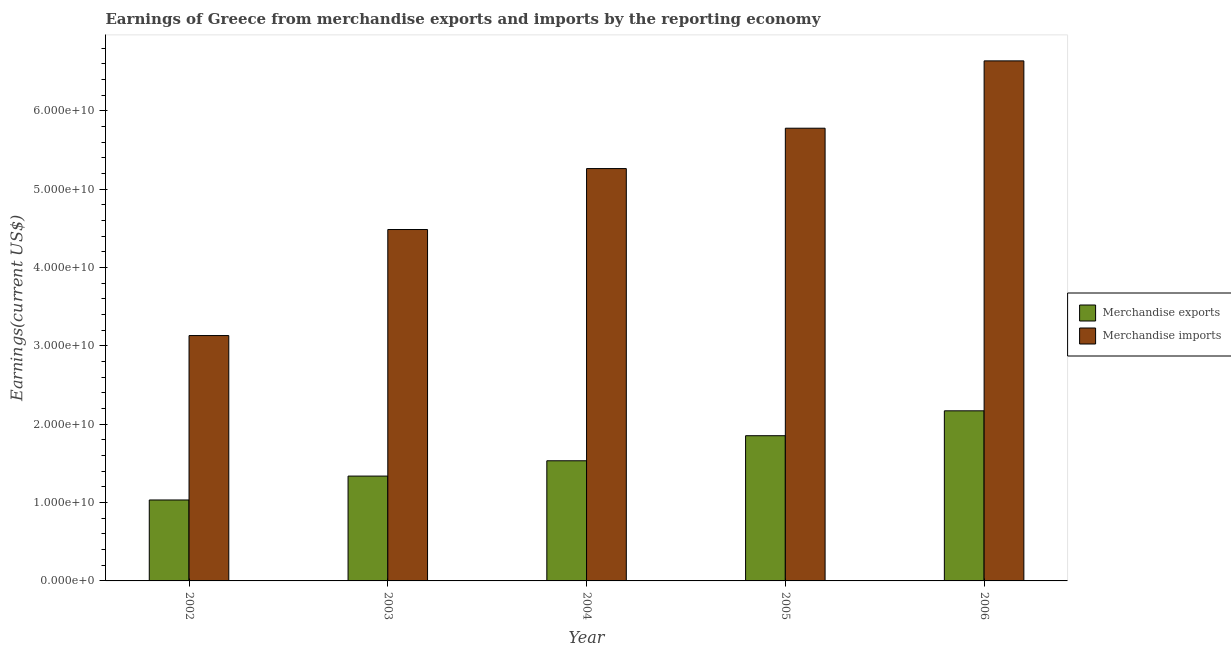How many different coloured bars are there?
Provide a succinct answer. 2. Are the number of bars per tick equal to the number of legend labels?
Make the answer very short. Yes. Are the number of bars on each tick of the X-axis equal?
Your answer should be compact. Yes. How many bars are there on the 1st tick from the right?
Offer a terse response. 2. What is the earnings from merchandise imports in 2005?
Your response must be concise. 5.78e+1. Across all years, what is the maximum earnings from merchandise exports?
Provide a succinct answer. 2.17e+1. Across all years, what is the minimum earnings from merchandise exports?
Your answer should be compact. 1.03e+1. In which year was the earnings from merchandise exports minimum?
Keep it short and to the point. 2002. What is the total earnings from merchandise exports in the graph?
Ensure brevity in your answer.  7.93e+1. What is the difference between the earnings from merchandise imports in 2002 and that in 2006?
Your response must be concise. -3.51e+1. What is the difference between the earnings from merchandise exports in 2003 and the earnings from merchandise imports in 2005?
Provide a short and direct response. -5.15e+09. What is the average earnings from merchandise exports per year?
Give a very brief answer. 1.59e+1. What is the ratio of the earnings from merchandise imports in 2002 to that in 2004?
Your answer should be compact. 0.6. Is the earnings from merchandise exports in 2004 less than that in 2005?
Ensure brevity in your answer.  Yes. Is the difference between the earnings from merchandise imports in 2003 and 2005 greater than the difference between the earnings from merchandise exports in 2003 and 2005?
Your response must be concise. No. What is the difference between the highest and the second highest earnings from merchandise imports?
Provide a succinct answer. 8.60e+09. What is the difference between the highest and the lowest earnings from merchandise imports?
Make the answer very short. 3.51e+1. What does the 2nd bar from the left in 2003 represents?
Make the answer very short. Merchandise imports. How many bars are there?
Your response must be concise. 10. Are all the bars in the graph horizontal?
Keep it short and to the point. No. How many years are there in the graph?
Provide a short and direct response. 5. Are the values on the major ticks of Y-axis written in scientific E-notation?
Your answer should be very brief. Yes. Does the graph contain any zero values?
Offer a terse response. No. Where does the legend appear in the graph?
Keep it short and to the point. Center right. How are the legend labels stacked?
Keep it short and to the point. Vertical. What is the title of the graph?
Your answer should be compact. Earnings of Greece from merchandise exports and imports by the reporting economy. What is the label or title of the Y-axis?
Provide a short and direct response. Earnings(current US$). What is the Earnings(current US$) in Merchandise exports in 2002?
Ensure brevity in your answer.  1.03e+1. What is the Earnings(current US$) in Merchandise imports in 2002?
Offer a very short reply. 3.13e+1. What is the Earnings(current US$) of Merchandise exports in 2003?
Give a very brief answer. 1.34e+1. What is the Earnings(current US$) of Merchandise imports in 2003?
Ensure brevity in your answer.  4.49e+1. What is the Earnings(current US$) in Merchandise exports in 2004?
Provide a short and direct response. 1.53e+1. What is the Earnings(current US$) of Merchandise imports in 2004?
Provide a succinct answer. 5.26e+1. What is the Earnings(current US$) of Merchandise exports in 2005?
Keep it short and to the point. 1.85e+1. What is the Earnings(current US$) in Merchandise imports in 2005?
Your answer should be very brief. 5.78e+1. What is the Earnings(current US$) of Merchandise exports in 2006?
Ensure brevity in your answer.  2.17e+1. What is the Earnings(current US$) of Merchandise imports in 2006?
Your answer should be very brief. 6.64e+1. Across all years, what is the maximum Earnings(current US$) of Merchandise exports?
Offer a terse response. 2.17e+1. Across all years, what is the maximum Earnings(current US$) in Merchandise imports?
Offer a very short reply. 6.64e+1. Across all years, what is the minimum Earnings(current US$) of Merchandise exports?
Your answer should be very brief. 1.03e+1. Across all years, what is the minimum Earnings(current US$) in Merchandise imports?
Offer a very short reply. 3.13e+1. What is the total Earnings(current US$) in Merchandise exports in the graph?
Give a very brief answer. 7.93e+1. What is the total Earnings(current US$) of Merchandise imports in the graph?
Offer a very short reply. 2.53e+11. What is the difference between the Earnings(current US$) in Merchandise exports in 2002 and that in 2003?
Ensure brevity in your answer.  -3.05e+09. What is the difference between the Earnings(current US$) of Merchandise imports in 2002 and that in 2003?
Offer a terse response. -1.35e+1. What is the difference between the Earnings(current US$) of Merchandise exports in 2002 and that in 2004?
Provide a succinct answer. -5.00e+09. What is the difference between the Earnings(current US$) in Merchandise imports in 2002 and that in 2004?
Make the answer very short. -2.13e+1. What is the difference between the Earnings(current US$) in Merchandise exports in 2002 and that in 2005?
Ensure brevity in your answer.  -8.20e+09. What is the difference between the Earnings(current US$) in Merchandise imports in 2002 and that in 2005?
Provide a short and direct response. -2.65e+1. What is the difference between the Earnings(current US$) of Merchandise exports in 2002 and that in 2006?
Provide a short and direct response. -1.14e+1. What is the difference between the Earnings(current US$) in Merchandise imports in 2002 and that in 2006?
Keep it short and to the point. -3.51e+1. What is the difference between the Earnings(current US$) in Merchandise exports in 2003 and that in 2004?
Your answer should be compact. -1.96e+09. What is the difference between the Earnings(current US$) of Merchandise imports in 2003 and that in 2004?
Ensure brevity in your answer.  -7.78e+09. What is the difference between the Earnings(current US$) in Merchandise exports in 2003 and that in 2005?
Offer a very short reply. -5.15e+09. What is the difference between the Earnings(current US$) of Merchandise imports in 2003 and that in 2005?
Your answer should be very brief. -1.29e+1. What is the difference between the Earnings(current US$) in Merchandise exports in 2003 and that in 2006?
Provide a succinct answer. -8.33e+09. What is the difference between the Earnings(current US$) of Merchandise imports in 2003 and that in 2006?
Give a very brief answer. -2.15e+1. What is the difference between the Earnings(current US$) of Merchandise exports in 2004 and that in 2005?
Your answer should be very brief. -3.20e+09. What is the difference between the Earnings(current US$) in Merchandise imports in 2004 and that in 2005?
Your answer should be very brief. -5.15e+09. What is the difference between the Earnings(current US$) in Merchandise exports in 2004 and that in 2006?
Offer a terse response. -6.37e+09. What is the difference between the Earnings(current US$) in Merchandise imports in 2004 and that in 2006?
Provide a short and direct response. -1.37e+1. What is the difference between the Earnings(current US$) of Merchandise exports in 2005 and that in 2006?
Provide a short and direct response. -3.18e+09. What is the difference between the Earnings(current US$) in Merchandise imports in 2005 and that in 2006?
Your answer should be compact. -8.60e+09. What is the difference between the Earnings(current US$) of Merchandise exports in 2002 and the Earnings(current US$) of Merchandise imports in 2003?
Keep it short and to the point. -3.45e+1. What is the difference between the Earnings(current US$) of Merchandise exports in 2002 and the Earnings(current US$) of Merchandise imports in 2004?
Provide a succinct answer. -4.23e+1. What is the difference between the Earnings(current US$) in Merchandise exports in 2002 and the Earnings(current US$) in Merchandise imports in 2005?
Your response must be concise. -4.75e+1. What is the difference between the Earnings(current US$) in Merchandise exports in 2002 and the Earnings(current US$) in Merchandise imports in 2006?
Give a very brief answer. -5.60e+1. What is the difference between the Earnings(current US$) of Merchandise exports in 2003 and the Earnings(current US$) of Merchandise imports in 2004?
Offer a terse response. -3.93e+1. What is the difference between the Earnings(current US$) of Merchandise exports in 2003 and the Earnings(current US$) of Merchandise imports in 2005?
Keep it short and to the point. -4.44e+1. What is the difference between the Earnings(current US$) of Merchandise exports in 2003 and the Earnings(current US$) of Merchandise imports in 2006?
Offer a very short reply. -5.30e+1. What is the difference between the Earnings(current US$) in Merchandise exports in 2004 and the Earnings(current US$) in Merchandise imports in 2005?
Provide a succinct answer. -4.24e+1. What is the difference between the Earnings(current US$) in Merchandise exports in 2004 and the Earnings(current US$) in Merchandise imports in 2006?
Make the answer very short. -5.10e+1. What is the difference between the Earnings(current US$) of Merchandise exports in 2005 and the Earnings(current US$) of Merchandise imports in 2006?
Offer a very short reply. -4.78e+1. What is the average Earnings(current US$) in Merchandise exports per year?
Provide a short and direct response. 1.59e+1. What is the average Earnings(current US$) of Merchandise imports per year?
Offer a very short reply. 5.06e+1. In the year 2002, what is the difference between the Earnings(current US$) in Merchandise exports and Earnings(current US$) in Merchandise imports?
Give a very brief answer. -2.10e+1. In the year 2003, what is the difference between the Earnings(current US$) in Merchandise exports and Earnings(current US$) in Merchandise imports?
Give a very brief answer. -3.15e+1. In the year 2004, what is the difference between the Earnings(current US$) in Merchandise exports and Earnings(current US$) in Merchandise imports?
Your response must be concise. -3.73e+1. In the year 2005, what is the difference between the Earnings(current US$) in Merchandise exports and Earnings(current US$) in Merchandise imports?
Your response must be concise. -3.92e+1. In the year 2006, what is the difference between the Earnings(current US$) in Merchandise exports and Earnings(current US$) in Merchandise imports?
Give a very brief answer. -4.47e+1. What is the ratio of the Earnings(current US$) of Merchandise exports in 2002 to that in 2003?
Keep it short and to the point. 0.77. What is the ratio of the Earnings(current US$) in Merchandise imports in 2002 to that in 2003?
Provide a succinct answer. 0.7. What is the ratio of the Earnings(current US$) of Merchandise exports in 2002 to that in 2004?
Make the answer very short. 0.67. What is the ratio of the Earnings(current US$) in Merchandise imports in 2002 to that in 2004?
Give a very brief answer. 0.59. What is the ratio of the Earnings(current US$) of Merchandise exports in 2002 to that in 2005?
Ensure brevity in your answer.  0.56. What is the ratio of the Earnings(current US$) of Merchandise imports in 2002 to that in 2005?
Ensure brevity in your answer.  0.54. What is the ratio of the Earnings(current US$) in Merchandise exports in 2002 to that in 2006?
Your response must be concise. 0.48. What is the ratio of the Earnings(current US$) in Merchandise imports in 2002 to that in 2006?
Your answer should be very brief. 0.47. What is the ratio of the Earnings(current US$) in Merchandise exports in 2003 to that in 2004?
Provide a succinct answer. 0.87. What is the ratio of the Earnings(current US$) of Merchandise imports in 2003 to that in 2004?
Provide a short and direct response. 0.85. What is the ratio of the Earnings(current US$) in Merchandise exports in 2003 to that in 2005?
Your answer should be compact. 0.72. What is the ratio of the Earnings(current US$) of Merchandise imports in 2003 to that in 2005?
Provide a short and direct response. 0.78. What is the ratio of the Earnings(current US$) of Merchandise exports in 2003 to that in 2006?
Your response must be concise. 0.62. What is the ratio of the Earnings(current US$) in Merchandise imports in 2003 to that in 2006?
Provide a succinct answer. 0.68. What is the ratio of the Earnings(current US$) in Merchandise exports in 2004 to that in 2005?
Offer a very short reply. 0.83. What is the ratio of the Earnings(current US$) in Merchandise imports in 2004 to that in 2005?
Your answer should be very brief. 0.91. What is the ratio of the Earnings(current US$) of Merchandise exports in 2004 to that in 2006?
Your answer should be compact. 0.71. What is the ratio of the Earnings(current US$) in Merchandise imports in 2004 to that in 2006?
Provide a short and direct response. 0.79. What is the ratio of the Earnings(current US$) in Merchandise exports in 2005 to that in 2006?
Provide a short and direct response. 0.85. What is the ratio of the Earnings(current US$) in Merchandise imports in 2005 to that in 2006?
Keep it short and to the point. 0.87. What is the difference between the highest and the second highest Earnings(current US$) of Merchandise exports?
Provide a short and direct response. 3.18e+09. What is the difference between the highest and the second highest Earnings(current US$) of Merchandise imports?
Provide a succinct answer. 8.60e+09. What is the difference between the highest and the lowest Earnings(current US$) in Merchandise exports?
Offer a terse response. 1.14e+1. What is the difference between the highest and the lowest Earnings(current US$) in Merchandise imports?
Provide a short and direct response. 3.51e+1. 